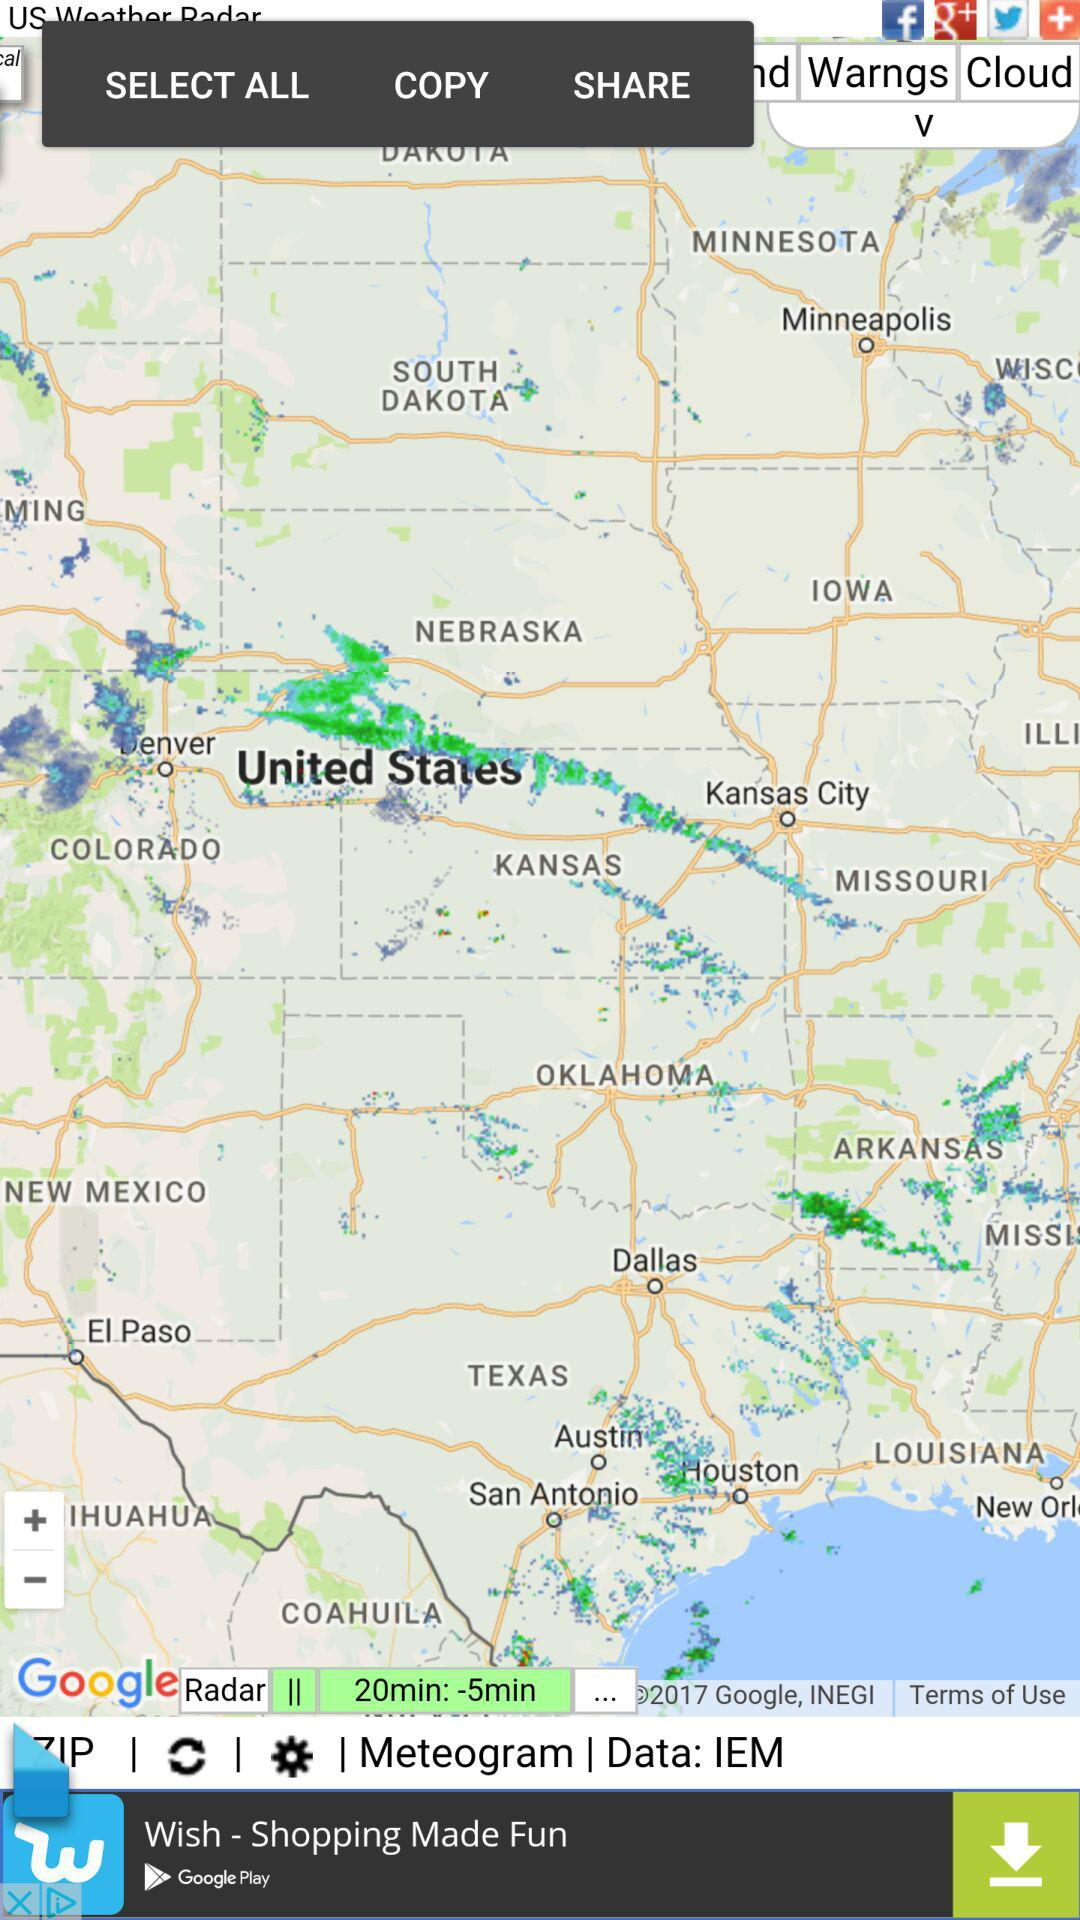Through which applications can we share? You can share through the "Facebook", "Google+" and "Twitter" applications. 